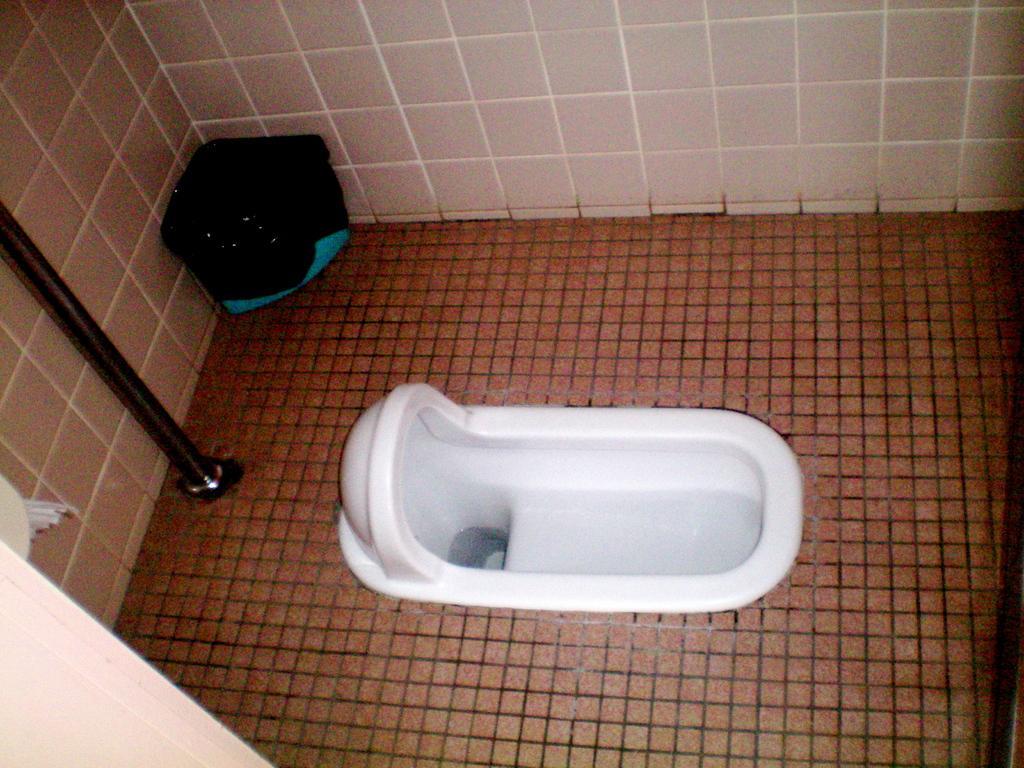Describe this image in one or two sentences. This image is taken in the bathroom. In the center of the image there is a toilet. In the background there is a wall and we can see a bin. We can see a rod. 